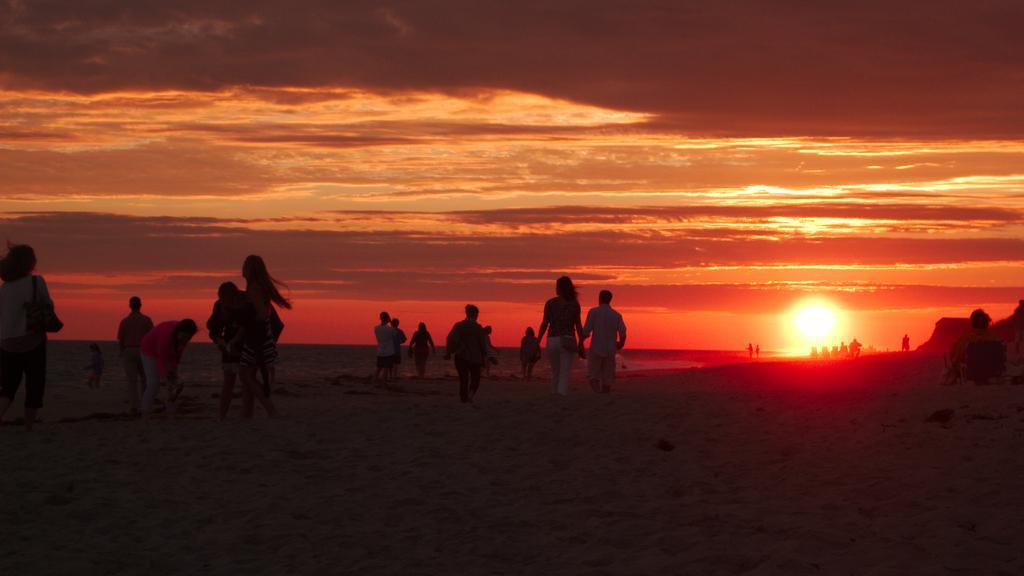Can you describe this image briefly? There are many people on the sea shore. In the background there is sky with sun and clouds and the sky is in red color. 